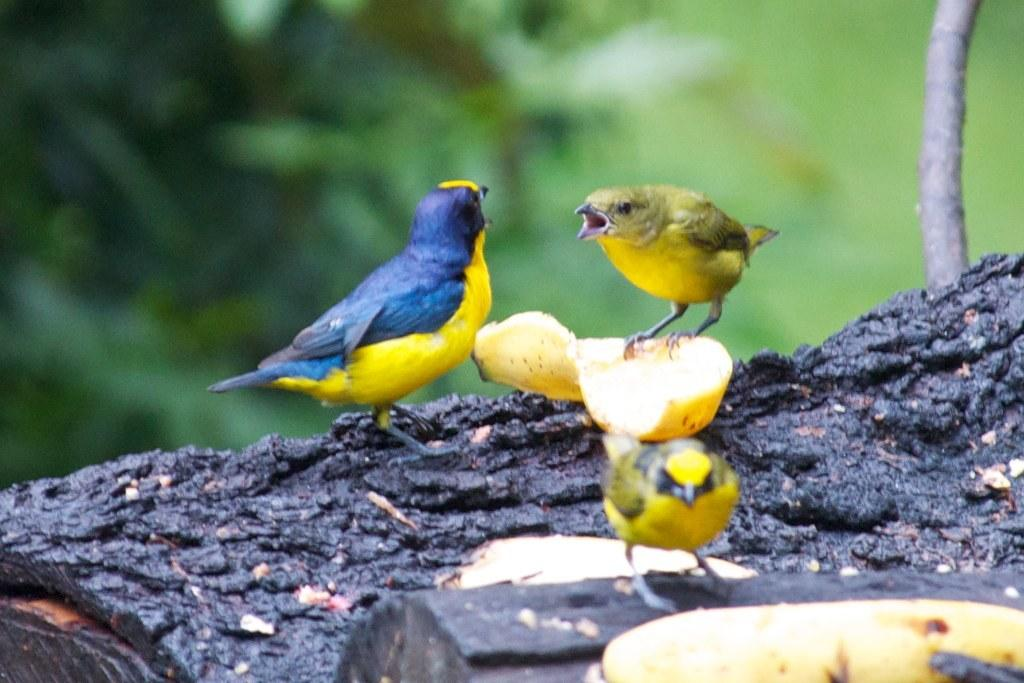What are the birds doing in the image? The birds are standing on a tree trunk and a banana peel in the image. What is located near the birds? There is a banana in the bottom right of the image. How would you describe the background of the image? The background of the image is blurry. What type of paste is being used by the birds to stick the apple to the tree trunk? There is no paste or apple present in the image; the birds are standing on a tree trunk and a banana peel. What is the position of the sun in the image? The sun is not visible in the image, so its position cannot be determined. 